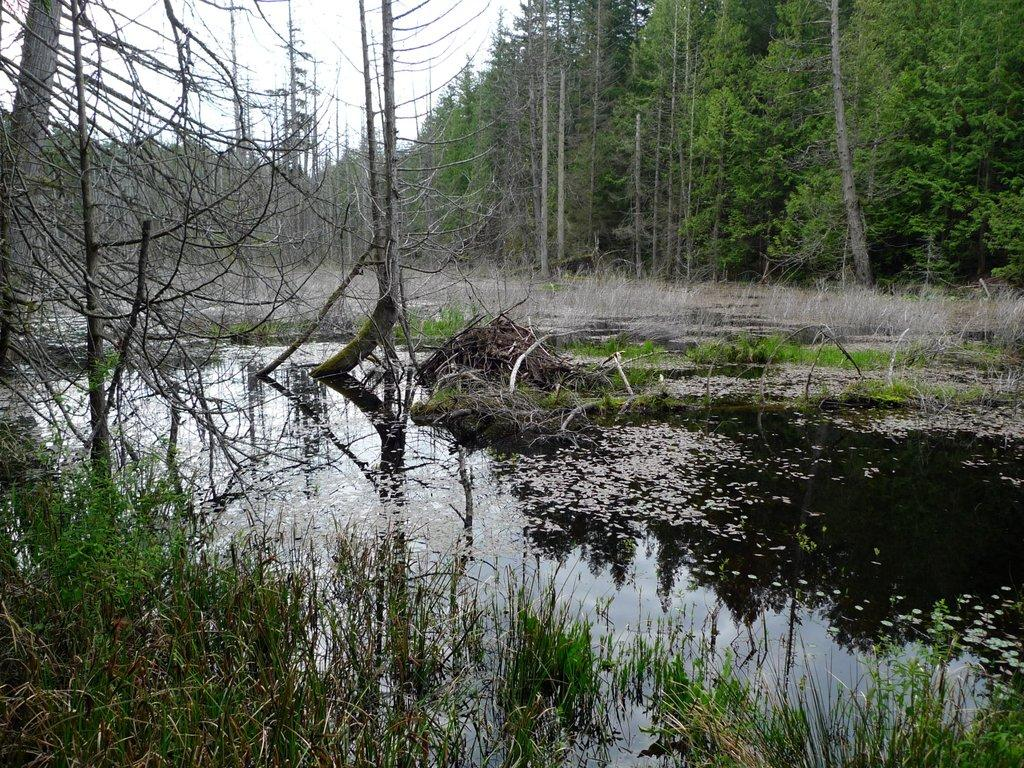What type of vegetation can be seen in the image? There are plants and a group of trees in the image. What is the terrain like in the image? There is water, grass, and trees visible in the image. What part of the trees can be seen in the image? The bark of the trees is visible in the image. What is visible in the background of the image? The sky is visible in the image. What type of behavior can be observed in the bikes in the image? There are no bikes present in the image, so no behavior can be observed. 